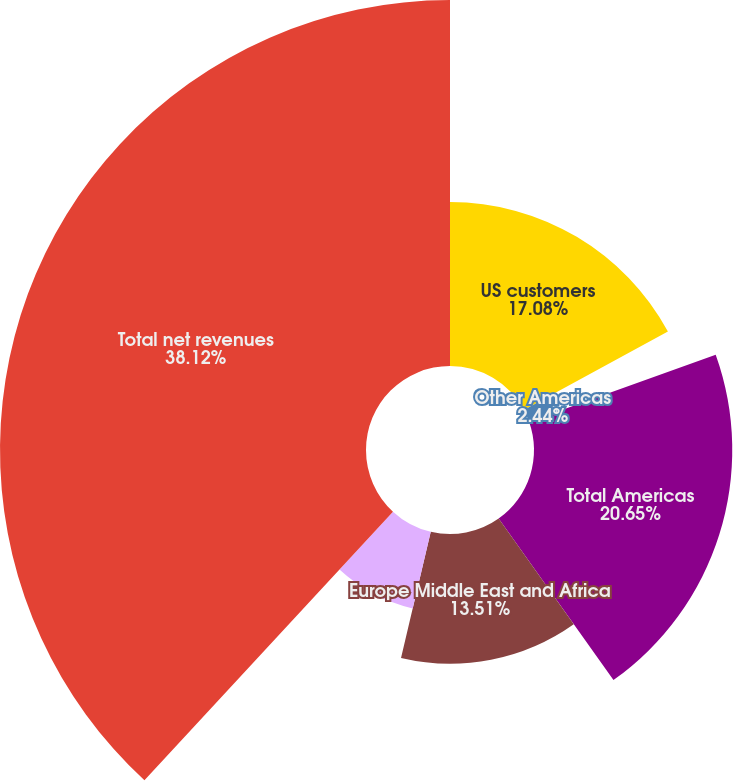Convert chart. <chart><loc_0><loc_0><loc_500><loc_500><pie_chart><fcel>US customers<fcel>Other Americas<fcel>Total Americas<fcel>Europe Middle East and Africa<fcel>Asia Pacific<fcel>Total net revenues<nl><fcel>17.08%<fcel>2.44%<fcel>20.65%<fcel>13.51%<fcel>8.2%<fcel>38.12%<nl></chart> 